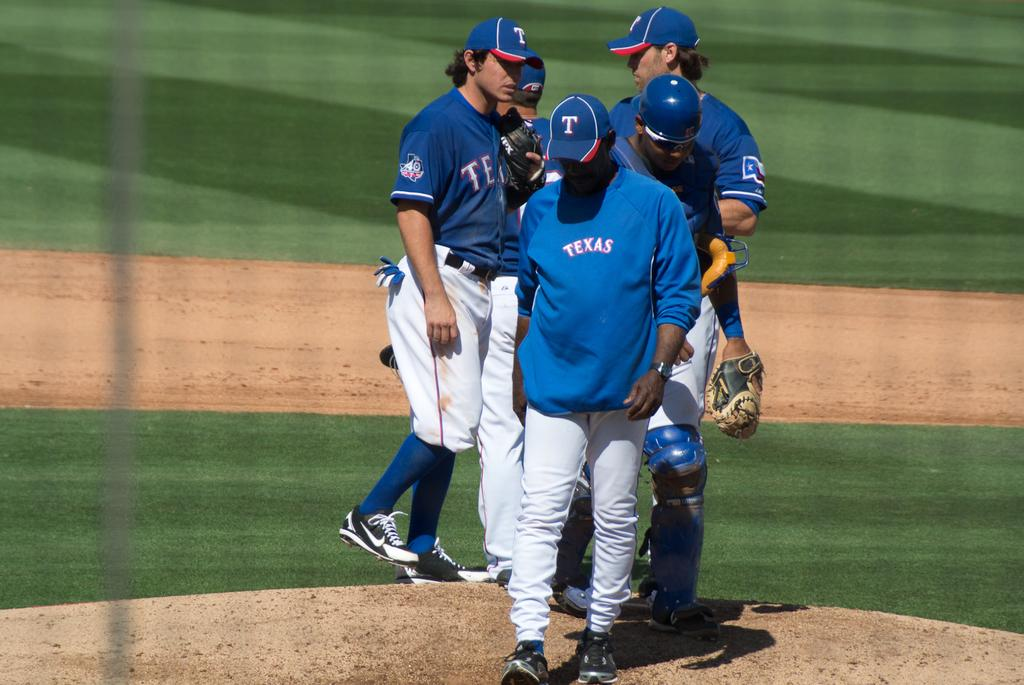Provide a one-sentence caption for the provided image. A  group of five men at the pitchers mound with TEXAS shirts and jerseys. 